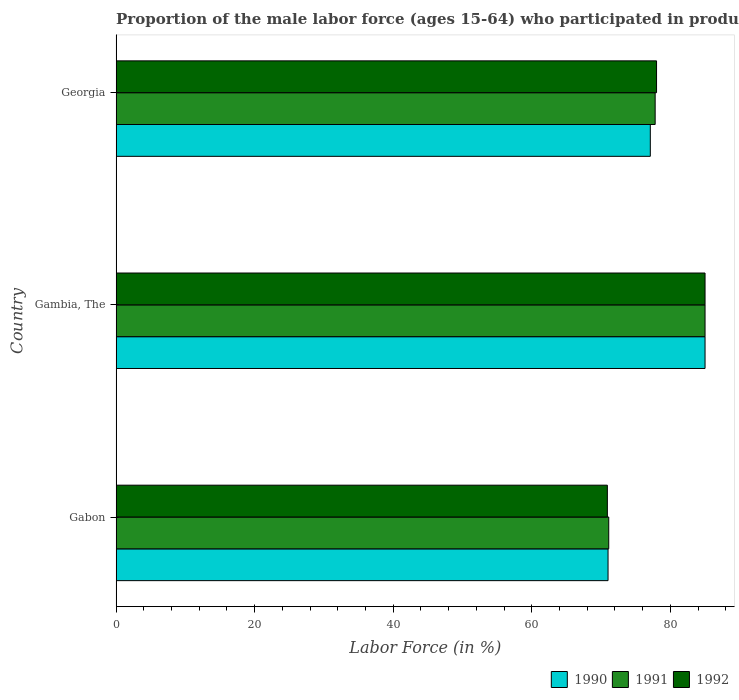How many different coloured bars are there?
Ensure brevity in your answer.  3. How many groups of bars are there?
Ensure brevity in your answer.  3. How many bars are there on the 3rd tick from the top?
Ensure brevity in your answer.  3. How many bars are there on the 3rd tick from the bottom?
Offer a very short reply. 3. What is the label of the 3rd group of bars from the top?
Offer a very short reply. Gabon. What is the proportion of the male labor force who participated in production in 1990 in Gambia, The?
Give a very brief answer. 85. Across all countries, what is the maximum proportion of the male labor force who participated in production in 1990?
Make the answer very short. 85. Across all countries, what is the minimum proportion of the male labor force who participated in production in 1992?
Give a very brief answer. 70.9. In which country was the proportion of the male labor force who participated in production in 1990 maximum?
Your response must be concise. Gambia, The. In which country was the proportion of the male labor force who participated in production in 1991 minimum?
Ensure brevity in your answer.  Gabon. What is the total proportion of the male labor force who participated in production in 1990 in the graph?
Your answer should be compact. 233.1. What is the difference between the proportion of the male labor force who participated in production in 1991 in Gabon and that in Georgia?
Ensure brevity in your answer.  -6.7. What is the difference between the proportion of the male labor force who participated in production in 1990 in Gambia, The and the proportion of the male labor force who participated in production in 1991 in Georgia?
Offer a very short reply. 7.2. What is the average proportion of the male labor force who participated in production in 1991 per country?
Make the answer very short. 77.97. What is the difference between the proportion of the male labor force who participated in production in 1992 and proportion of the male labor force who participated in production in 1991 in Gabon?
Your answer should be compact. -0.2. In how many countries, is the proportion of the male labor force who participated in production in 1992 greater than 44 %?
Give a very brief answer. 3. What is the ratio of the proportion of the male labor force who participated in production in 1991 in Gabon to that in Gambia, The?
Offer a terse response. 0.84. Is the difference between the proportion of the male labor force who participated in production in 1992 in Gambia, The and Georgia greater than the difference between the proportion of the male labor force who participated in production in 1991 in Gambia, The and Georgia?
Provide a short and direct response. No. What is the difference between the highest and the second highest proportion of the male labor force who participated in production in 1990?
Make the answer very short. 7.9. What is the difference between the highest and the lowest proportion of the male labor force who participated in production in 1992?
Provide a succinct answer. 14.1. In how many countries, is the proportion of the male labor force who participated in production in 1992 greater than the average proportion of the male labor force who participated in production in 1992 taken over all countries?
Your answer should be compact. 2. Is the sum of the proportion of the male labor force who participated in production in 1991 in Gambia, The and Georgia greater than the maximum proportion of the male labor force who participated in production in 1990 across all countries?
Offer a terse response. Yes. What does the 1st bar from the top in Gabon represents?
Keep it short and to the point. 1992. What does the 1st bar from the bottom in Gabon represents?
Provide a succinct answer. 1990. How many bars are there?
Your answer should be compact. 9. Are all the bars in the graph horizontal?
Provide a succinct answer. Yes. How many countries are there in the graph?
Offer a terse response. 3. What is the difference between two consecutive major ticks on the X-axis?
Keep it short and to the point. 20. Does the graph contain any zero values?
Provide a short and direct response. No. How many legend labels are there?
Your answer should be very brief. 3. What is the title of the graph?
Provide a short and direct response. Proportion of the male labor force (ages 15-64) who participated in production. What is the label or title of the X-axis?
Ensure brevity in your answer.  Labor Force (in %). What is the label or title of the Y-axis?
Give a very brief answer. Country. What is the Labor Force (in %) in 1990 in Gabon?
Offer a very short reply. 71. What is the Labor Force (in %) in 1991 in Gabon?
Your response must be concise. 71.1. What is the Labor Force (in %) of 1992 in Gabon?
Ensure brevity in your answer.  70.9. What is the Labor Force (in %) of 1990 in Georgia?
Your answer should be very brief. 77.1. What is the Labor Force (in %) of 1991 in Georgia?
Offer a very short reply. 77.8. Across all countries, what is the maximum Labor Force (in %) in 1990?
Offer a terse response. 85. Across all countries, what is the maximum Labor Force (in %) in 1991?
Make the answer very short. 85. Across all countries, what is the maximum Labor Force (in %) in 1992?
Your answer should be very brief. 85. Across all countries, what is the minimum Labor Force (in %) in 1991?
Ensure brevity in your answer.  71.1. Across all countries, what is the minimum Labor Force (in %) in 1992?
Your answer should be compact. 70.9. What is the total Labor Force (in %) of 1990 in the graph?
Offer a very short reply. 233.1. What is the total Labor Force (in %) of 1991 in the graph?
Make the answer very short. 233.9. What is the total Labor Force (in %) of 1992 in the graph?
Make the answer very short. 233.9. What is the difference between the Labor Force (in %) in 1990 in Gabon and that in Gambia, The?
Provide a short and direct response. -14. What is the difference between the Labor Force (in %) of 1991 in Gabon and that in Gambia, The?
Your response must be concise. -13.9. What is the difference between the Labor Force (in %) in 1992 in Gabon and that in Gambia, The?
Your answer should be compact. -14.1. What is the difference between the Labor Force (in %) in 1990 in Gabon and that in Georgia?
Make the answer very short. -6.1. What is the difference between the Labor Force (in %) of 1991 in Gabon and that in Georgia?
Offer a very short reply. -6.7. What is the difference between the Labor Force (in %) of 1990 in Gambia, The and that in Georgia?
Your answer should be compact. 7.9. What is the difference between the Labor Force (in %) of 1991 in Gambia, The and that in Georgia?
Give a very brief answer. 7.2. What is the difference between the Labor Force (in %) of 1992 in Gambia, The and that in Georgia?
Offer a very short reply. 7. What is the difference between the Labor Force (in %) in 1990 in Gabon and the Labor Force (in %) in 1992 in Gambia, The?
Offer a terse response. -14. What is the difference between the Labor Force (in %) of 1991 in Gabon and the Labor Force (in %) of 1992 in Gambia, The?
Your answer should be very brief. -13.9. What is the difference between the Labor Force (in %) in 1990 in Gabon and the Labor Force (in %) in 1992 in Georgia?
Your answer should be compact. -7. What is the difference between the Labor Force (in %) of 1991 in Gabon and the Labor Force (in %) of 1992 in Georgia?
Give a very brief answer. -6.9. What is the average Labor Force (in %) in 1990 per country?
Give a very brief answer. 77.7. What is the average Labor Force (in %) of 1991 per country?
Provide a succinct answer. 77.97. What is the average Labor Force (in %) in 1992 per country?
Ensure brevity in your answer.  77.97. What is the difference between the Labor Force (in %) of 1991 and Labor Force (in %) of 1992 in Gabon?
Make the answer very short. 0.2. What is the difference between the Labor Force (in %) of 1990 and Labor Force (in %) of 1991 in Gambia, The?
Ensure brevity in your answer.  0. What is the difference between the Labor Force (in %) of 1991 and Labor Force (in %) of 1992 in Gambia, The?
Your response must be concise. 0. What is the difference between the Labor Force (in %) of 1990 and Labor Force (in %) of 1992 in Georgia?
Ensure brevity in your answer.  -0.9. What is the difference between the Labor Force (in %) in 1991 and Labor Force (in %) in 1992 in Georgia?
Give a very brief answer. -0.2. What is the ratio of the Labor Force (in %) in 1990 in Gabon to that in Gambia, The?
Offer a very short reply. 0.84. What is the ratio of the Labor Force (in %) in 1991 in Gabon to that in Gambia, The?
Keep it short and to the point. 0.84. What is the ratio of the Labor Force (in %) in 1992 in Gabon to that in Gambia, The?
Your response must be concise. 0.83. What is the ratio of the Labor Force (in %) in 1990 in Gabon to that in Georgia?
Your response must be concise. 0.92. What is the ratio of the Labor Force (in %) of 1991 in Gabon to that in Georgia?
Offer a terse response. 0.91. What is the ratio of the Labor Force (in %) in 1992 in Gabon to that in Georgia?
Ensure brevity in your answer.  0.91. What is the ratio of the Labor Force (in %) of 1990 in Gambia, The to that in Georgia?
Offer a terse response. 1.1. What is the ratio of the Labor Force (in %) of 1991 in Gambia, The to that in Georgia?
Give a very brief answer. 1.09. What is the ratio of the Labor Force (in %) in 1992 in Gambia, The to that in Georgia?
Keep it short and to the point. 1.09. What is the difference between the highest and the second highest Labor Force (in %) of 1990?
Your answer should be compact. 7.9. What is the difference between the highest and the second highest Labor Force (in %) of 1991?
Your answer should be very brief. 7.2. What is the difference between the highest and the second highest Labor Force (in %) of 1992?
Ensure brevity in your answer.  7. What is the difference between the highest and the lowest Labor Force (in %) of 1991?
Your answer should be compact. 13.9. 